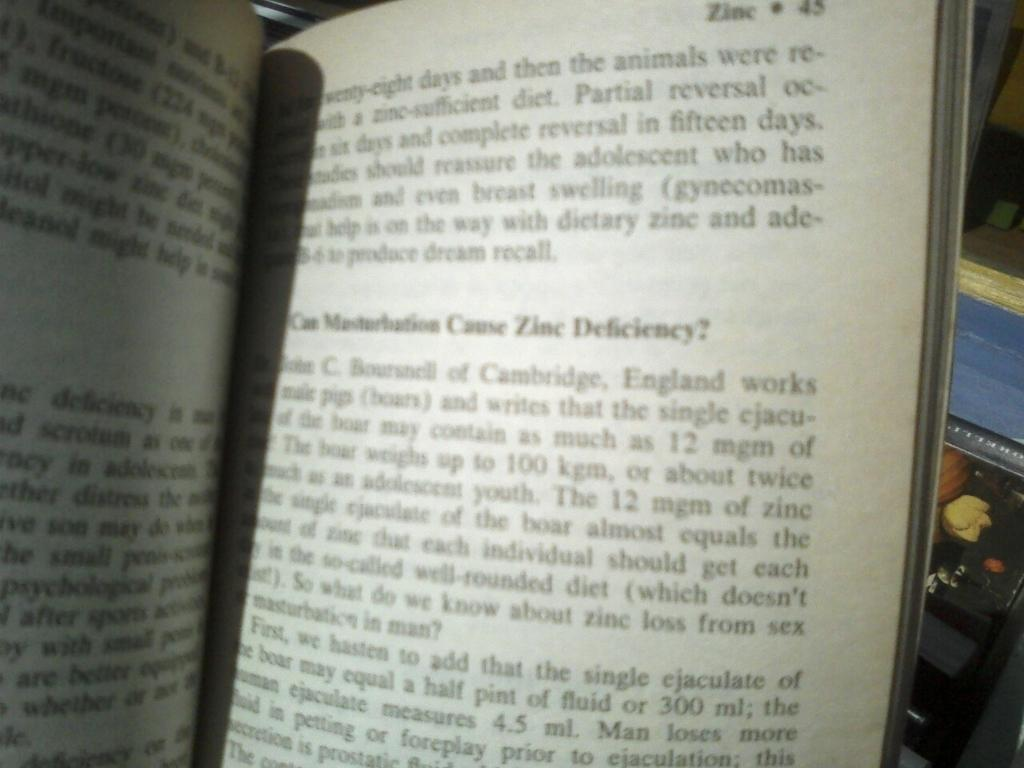Provide a one-sentence caption for the provided image. A chapter book about Zinc and the deficiency. 